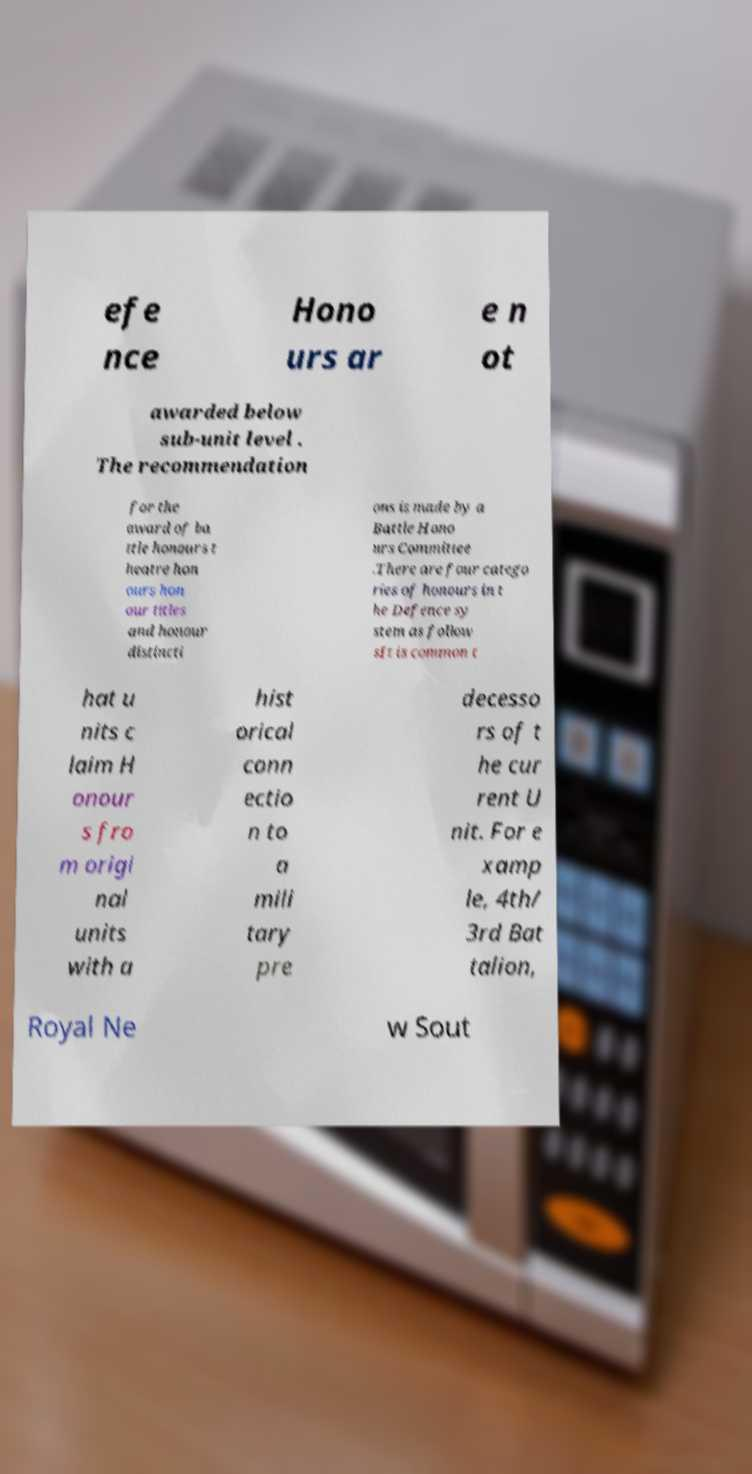I need the written content from this picture converted into text. Can you do that? efe nce Hono urs ar e n ot awarded below sub-unit level . The recommendation for the award of ba ttle honours t heatre hon ours hon our titles and honour distincti ons is made by a Battle Hono urs Committee .There are four catego ries of honours in t he Defence sy stem as follow sIt is common t hat u nits c laim H onour s fro m origi nal units with a hist orical conn ectio n to a mili tary pre decesso rs of t he cur rent U nit. For e xamp le, 4th/ 3rd Bat talion, Royal Ne w Sout 